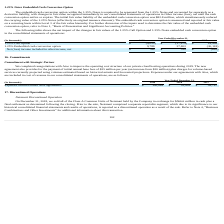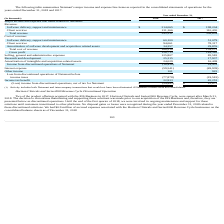According to Allscripts Healthcare Solutions's financial document, What was the exchange amount in cash for the Class A Common Units of Netsmart? According to the financial document, $566.6 million. The relevant text states: "ts of Netsmart held by the Company in exchange for $566.6 million in cash plus a..." Also, What was the Total revenue in 2018? According to the financial document, 345,231 (in thousands). The relevant text states: "Total revenue 345,231 308,634..." Also, What was the Client services revenue in 2018? According to the financial document, 131,166 (in thousands). The relevant text states: "Client services 131,166 110,430..." Also, can you calculate: What is the change in the Client services revenue from 2017 to 2018? Based on the calculation: 131,166 - 110,430, the result is 20736 (in thousands). This is based on the information: "Client services 131,166 110,430 Client services 131,166 110,430..." The key data points involved are: 110,430, 131,166. Also, can you calculate: What is the average Total cost of revenue for 2017-2018? To answer this question, I need to perform calculations using the financial data. The calculation is: (345,231 + 308,634) / 2, which equals 326932.5 (in thousands). This is based on the information: "Total revenue 345,231 308,634 Total revenue 345,231 308,634..." The key data points involved are: 308,634, 345,231. Also, can you calculate: What is the percentage change in the Gross profit from 2017 to 2018? To answer this question, I need to perform calculations using the financial data. The calculation is: 156,713 / 149,362 - 1, which equals 4.92 (percentage). This is based on the information: "Gross profit 156,713 149,362 Gross profit 156,713 149,362..." The key data points involved are: 149,362, 156,713. 